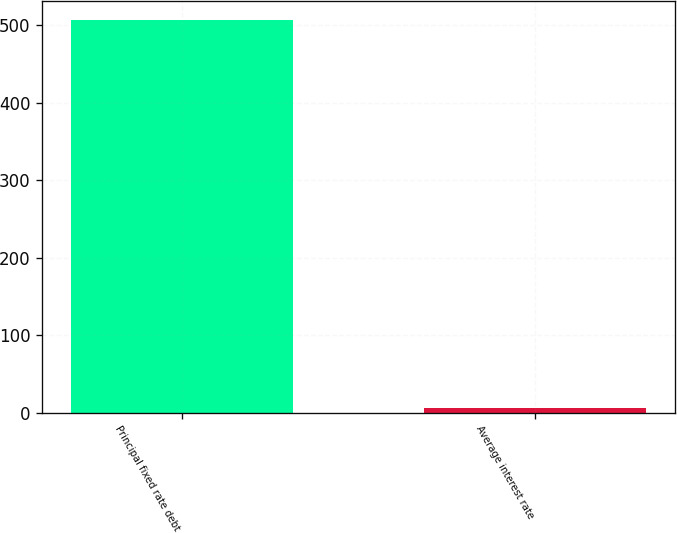Convert chart. <chart><loc_0><loc_0><loc_500><loc_500><bar_chart><fcel>Principal fixed rate debt<fcel>Average interest rate<nl><fcel>506.2<fcel>6.73<nl></chart> 